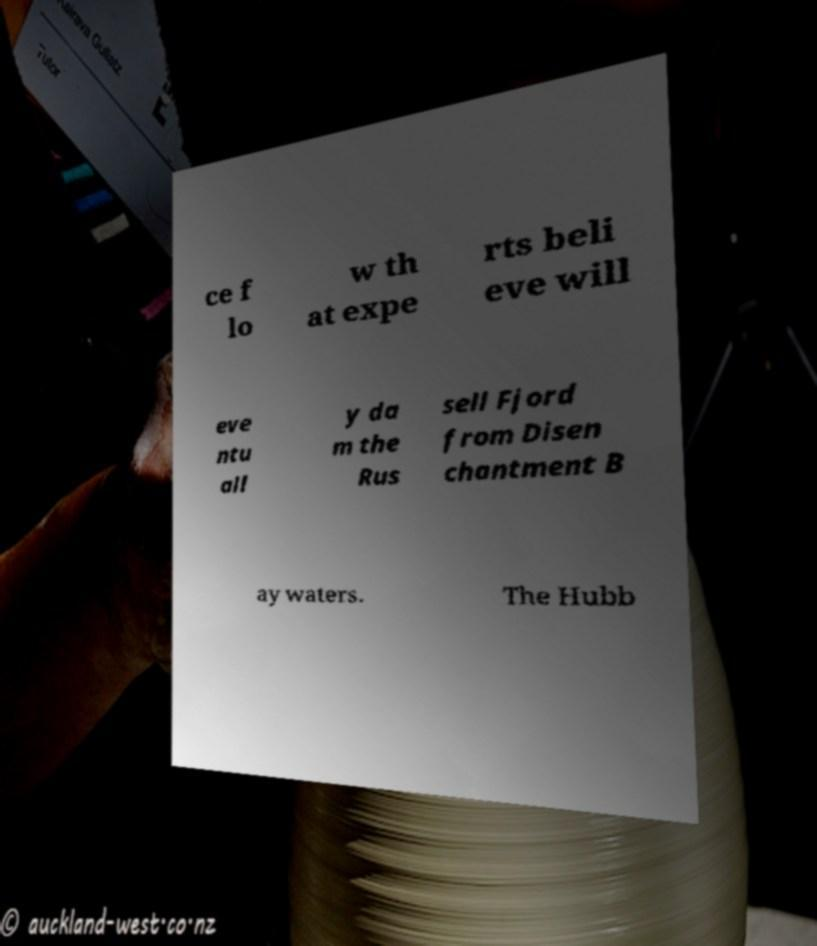Please read and relay the text visible in this image. What does it say? ce f lo w th at expe rts beli eve will eve ntu all y da m the Rus sell Fjord from Disen chantment B ay waters. The Hubb 